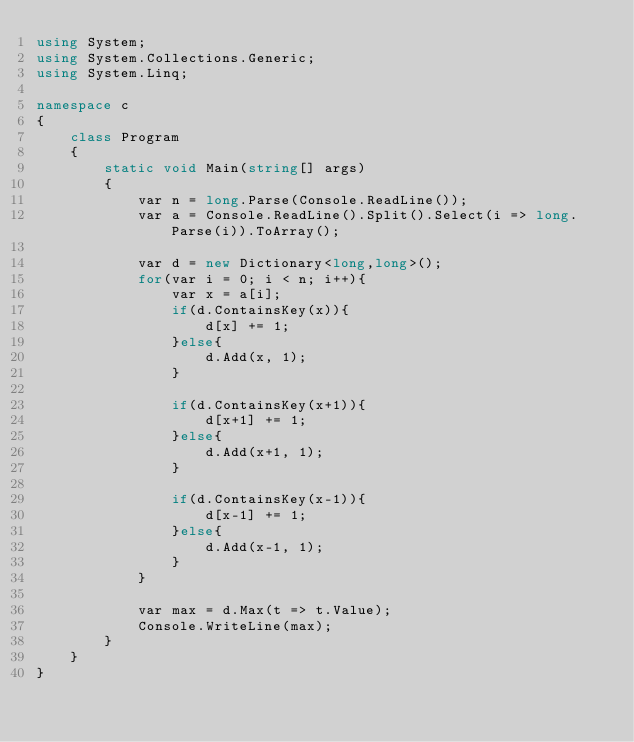Convert code to text. <code><loc_0><loc_0><loc_500><loc_500><_C#_>using System;
using System.Collections.Generic;
using System.Linq;

namespace c
{
    class Program
    {
        static void Main(string[] args)
        {
            var n = long.Parse(Console.ReadLine());
            var a = Console.ReadLine().Split().Select(i => long.Parse(i)).ToArray();

            var d = new Dictionary<long,long>();
            for(var i = 0; i < n; i++){
                var x = a[i];
                if(d.ContainsKey(x)){
                    d[x] += 1;
                }else{
                    d.Add(x, 1);
                }

                if(d.ContainsKey(x+1)){
                    d[x+1] += 1;
                }else{
                    d.Add(x+1, 1);
                }

                if(d.ContainsKey(x-1)){
                    d[x-1] += 1;
                }else{
                    d.Add(x-1, 1);
                }
            }

            var max = d.Max(t => t.Value);
            Console.WriteLine(max);
        }
    }
}
</code> 